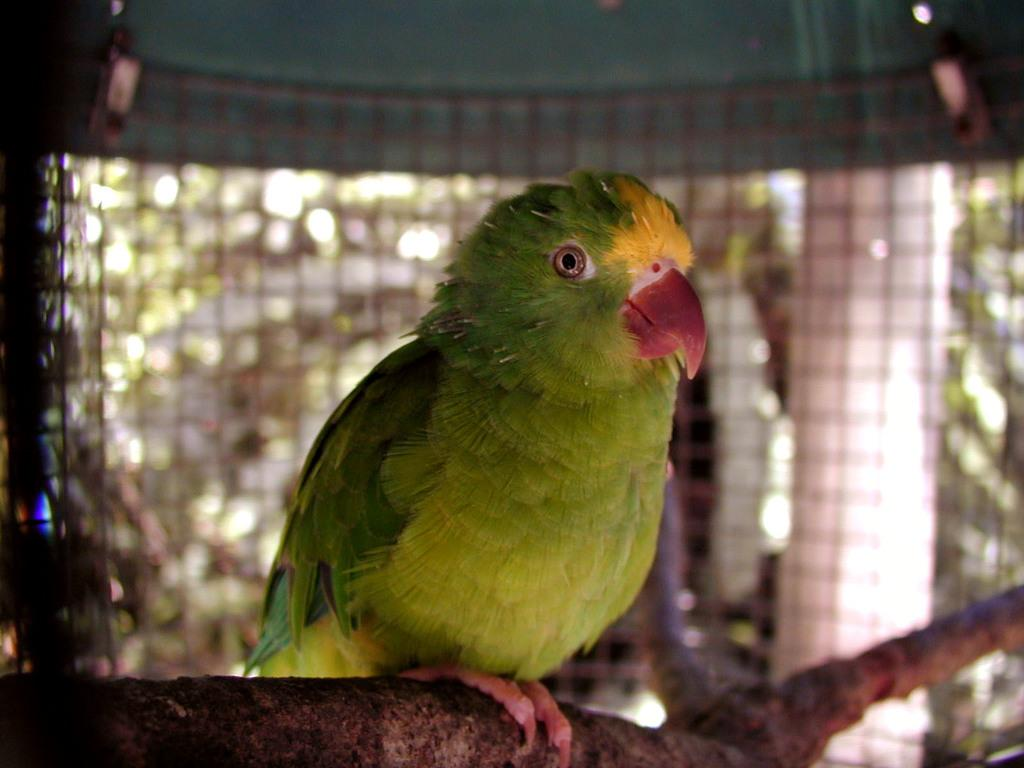What type of animal is in the image? There is a parrot in the image. Where is the parrot located? The parrot is on the branch of a tree. What other structures can be seen in the image? There is a pillar and a metal fence visible in the image. What type of needle is the parrot using to sew a board in the image? There is no needle or board present in the image; it only features a parrot on a tree branch, a pillar, and a metal fence. 